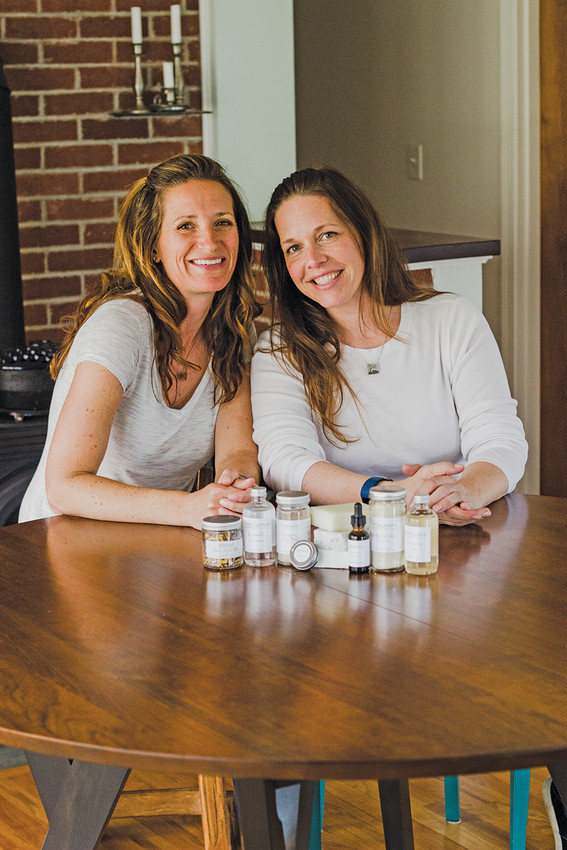What kind of setting are these individuals in, and how does it contribute to the overall impression of the scene? The individuals appear to be in a cozy and inviting home or studio setting, which features warm, natural lighting and a clean, organized table with various products displayed. This setting contributes to an impression of comfort and approachability, suggesting that their products are crafted in a personal and homely environment. It helps to convey a sense of authenticity and handmade quality, which can be very appealing to potential customers who value artisanal and genuine products. 